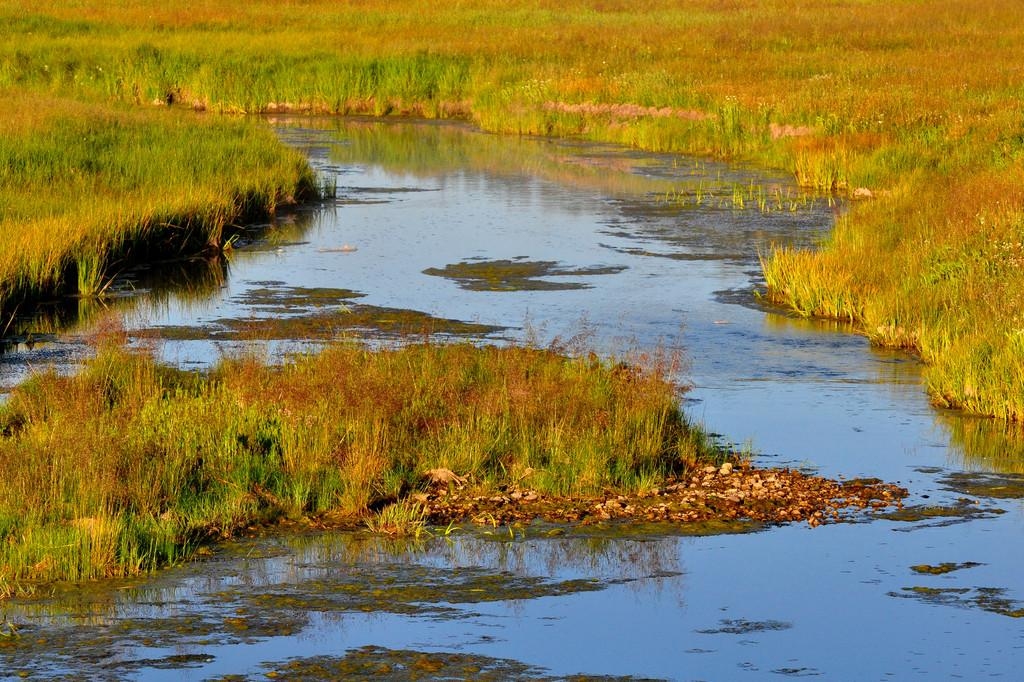What is the primary feature of the image? The primary feature of the image is a water surface. What type of landscape surrounds the water surface? There is grassland on either side of the water surface. What type of gold can be seen in the image? There is no gold present in the image; it features a water surface surrounded by grassland. What is the monkey eating for breakfast in the image? There is no monkey or breakfast present in the image. 